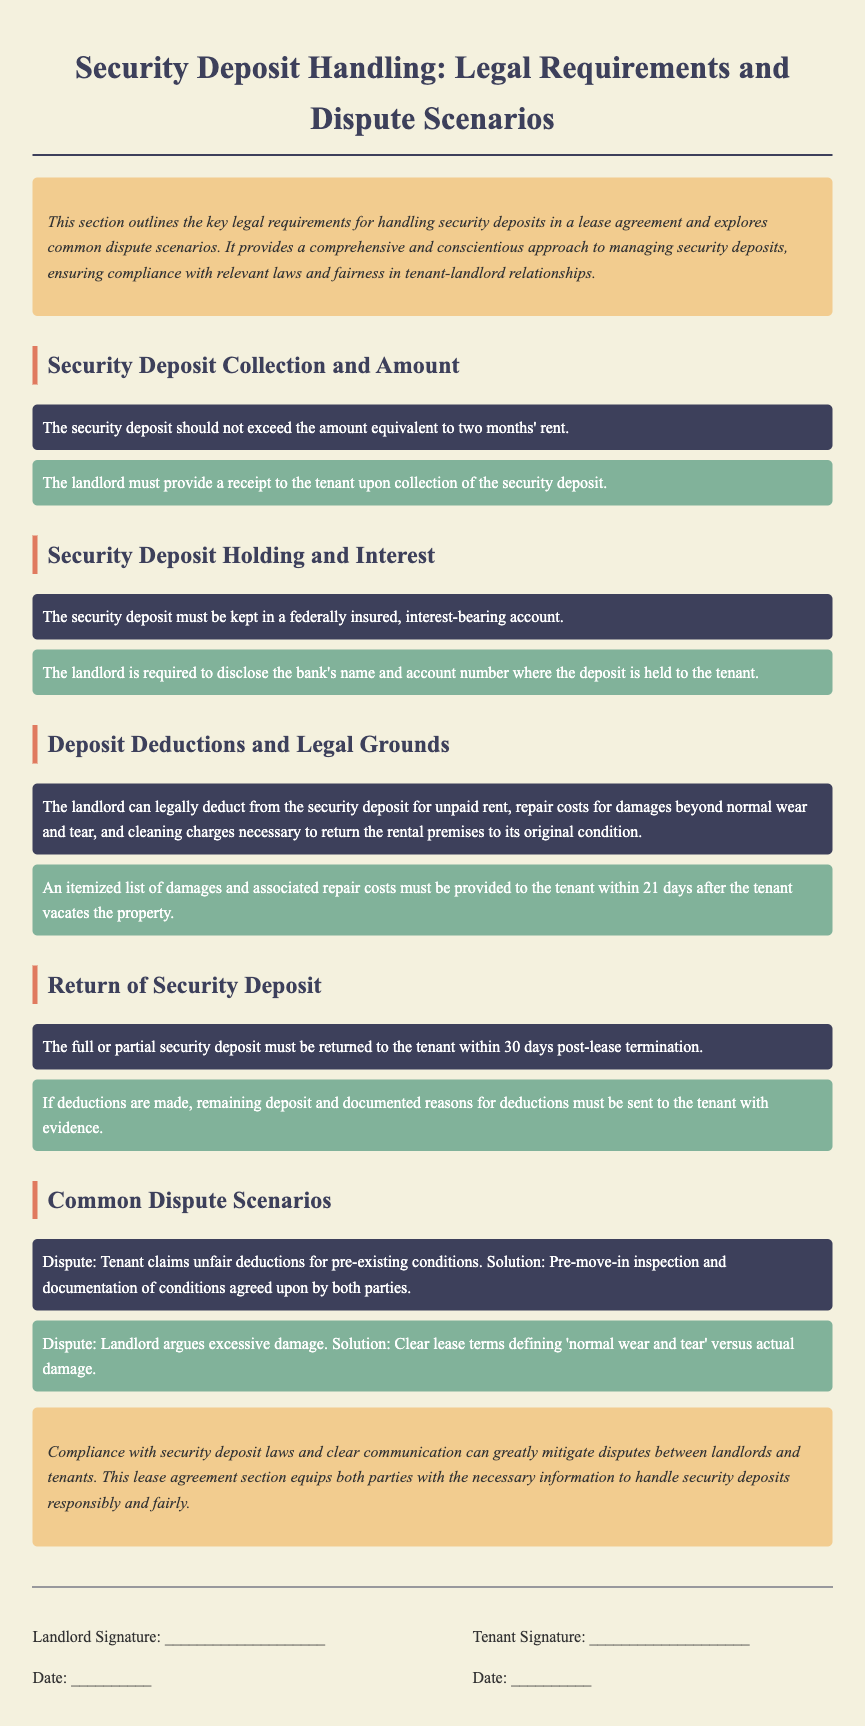What is the maximum security deposit amount? The maximum security deposit amount is specified in the section regarding security deposit collection, stating that it should not exceed the amount equivalent to two months' rent.
Answer: Two months' rent What must a landlord provide upon collecting the security deposit? The document mentions that the landlord must provide a receipt to the tenant upon collection of the security deposit.
Answer: A receipt Where must the security deposit be held? The requirements specify that the security deposit must be kept in a federally insured, interest-bearing account.
Answer: Federally insured, interest-bearing account What is the timeframe for returning the security deposit? The document states that the full or partial security deposit must be returned to the tenant within 30 days post-lease termination.
Answer: 30 days What is required if deductions are made from the security deposit? The document indicates that if deductions are made, the remaining deposit and documented reasons for deductions must be sent to the tenant with evidence.
Answer: Documented reasons and evidence What is one common dispute scenario mentioned? The document lists various disputes, specifically mentioning a dispute where the tenant claims unfair deductions for pre-existing conditions.
Answer: Unfair deductions for pre-existing conditions What must the landlord provide within 21 days after the tenant vacates? The section on deposit deductions specifies that the landlord must provide an itemized list of damages and associated repair costs to the tenant.
Answer: Itemized list of damages What does "normal wear and tear" relate to in the document? The document notes that clear lease terms defining 'normal wear and tear' versus actual damage are essential for resolving disputes regarding excessive damage claims.
Answer: Resolving disputes regarding excessive damage claims 